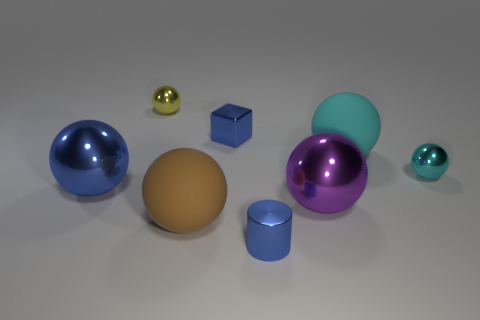Add 1 small green matte blocks. How many objects exist? 9 Subtract all blue spheres. How many spheres are left? 5 Subtract all large cyan balls. How many balls are left? 5 Subtract 0 yellow cubes. How many objects are left? 8 Subtract all cylinders. How many objects are left? 7 Subtract 1 cylinders. How many cylinders are left? 0 Subtract all cyan cylinders. Subtract all yellow blocks. How many cylinders are left? 1 Subtract all purple cubes. How many brown cylinders are left? 0 Subtract all tiny blue metal things. Subtract all tiny yellow spheres. How many objects are left? 5 Add 6 yellow balls. How many yellow balls are left? 7 